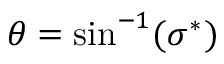<formula> <loc_0><loc_0><loc_500><loc_500>\theta = \sin ^ { - 1 } ( \sigma ^ { * } )</formula> 